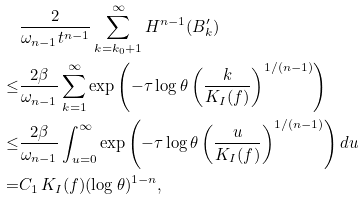<formula> <loc_0><loc_0><loc_500><loc_500>\quad & \frac { 2 } { \omega _ { n - 1 } t ^ { n - 1 } } \sum _ { k = k _ { 0 } + 1 } ^ { \infty } H ^ { n - 1 } ( B _ { k } ^ { \prime } ) \\ \leq & \frac { 2 \beta } { \omega _ { n - 1 } } \sum _ { k = 1 } ^ { \infty } \exp \left ( - \tau \log \theta \left ( \frac { k } { K _ { I } ( f ) } \right ) ^ { 1 / ( n - 1 ) } \right ) \\ \leq & \frac { 2 \beta } { \omega _ { n - 1 } } \int _ { u = 0 } ^ { \infty } \exp \left ( - \tau \log \theta \left ( \frac { u } { K _ { I } ( f ) } \right ) ^ { 1 / ( n - 1 ) } \right ) d u \\ = & C _ { 1 } \, K _ { I } ( f ) ( \log \theta ) ^ { 1 - n } ,</formula> 